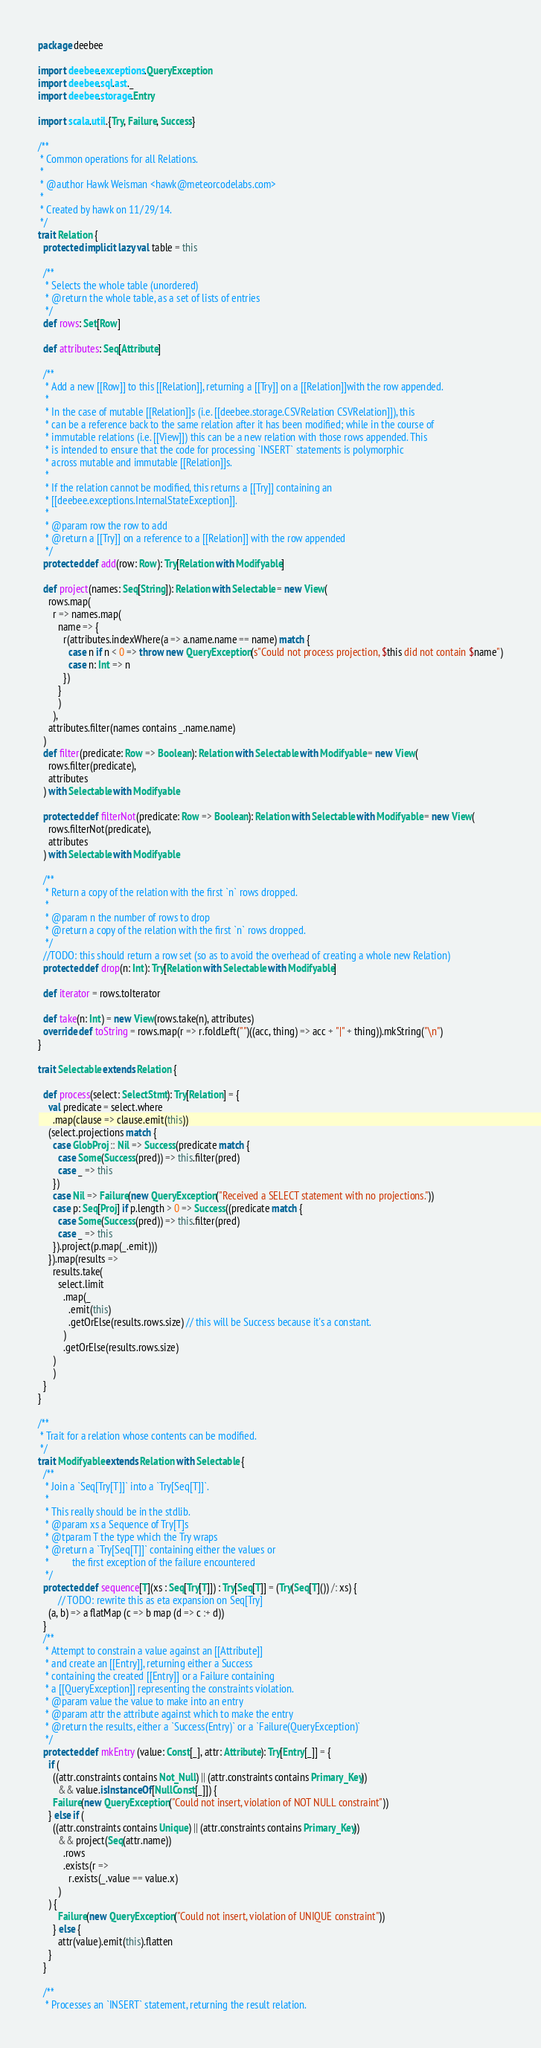<code> <loc_0><loc_0><loc_500><loc_500><_Scala_>package deebee

import deebee.exceptions.QueryException
import deebee.sql.ast._
import deebee.storage.Entry

import scala.util.{Try, Failure, Success}

/**
 * Common operations for all Relations.
 *
 * @author Hawk Weisman <hawk@meteorcodelabs.com>
 *
 * Created by hawk on 11/29/14.
 */
trait Relation {
  protected implicit lazy val table = this

  /**
   * Selects the whole table (unordered)
   * @return the whole table, as a set of lists of entries
   */
  def rows: Set[Row]

  def attributes: Seq[Attribute]

  /**
   * Add a new [[Row]] to this [[Relation]], returning a [[Try]] on a [[Relation]]with the row appended.
   *
   * In the case of mutable [[Relation]]s (i.e. [[deebee.storage.CSVRelation CSVRelation]]), this
   * can be a reference back to the same relation after it has been modified; while in the course of
   * immutable relations (i.e. [[View]]) this can be a new relation with those rows appended. This
   * is intended to ensure that the code for processing `INSERT` statements is polymorphic
   * across mutable and immutable [[Relation]]s.
   *
   * If the relation cannot be modified, this returns a [[Try]] containing an
   * [[deebee.exceptions.InternalStateException]].
   *
   * @param row the row to add
   * @return a [[Try]] on a reference to a [[Relation]] with the row appended
   */
  protected def add(row: Row): Try[Relation with Modifyable]

  def project(names: Seq[String]): Relation with Selectable = new View(
    rows.map(
      r => names.map(
        name => {
          r(attributes.indexWhere(a => a.name.name == name) match {
            case n if n < 0 => throw new QueryException(s"Could not process projection, $this did not contain $name")
            case n: Int => n
          })
        }
        )
      ),
    attributes.filter(names contains _.name.name)
  )
  def filter(predicate: Row => Boolean): Relation with Selectable with Modifyable = new View(
    rows.filter(predicate),
    attributes
  ) with Selectable with Modifyable

  protected def filterNot(predicate: Row => Boolean): Relation with Selectable with Modifyable = new View(
    rows.filterNot(predicate),
    attributes
  ) with Selectable with Modifyable

  /**
   * Return a copy of the relation with the first `n` rows dropped.
   *
   * @param n the number of rows to drop
   * @return a copy of the relation with the first `n` rows dropped.
   */
  //TODO: this should return a row set (so as to avoid the overhead of creating a whole new Relation)
  protected def drop(n: Int): Try[Relation with Selectable with Modifyable]

  def iterator = rows.toIterator

  def take(n: Int) = new View(rows.take(n), attributes)
  override def toString = rows.map(r => r.foldLeft("")((acc, thing) => acc + "|" + thing)).mkString("\n")
}

trait Selectable extends Relation {

  def process(select: SelectStmt): Try[Relation] = {
    val predicate = select.where
      .map(clause => clause.emit(this))
    (select.projections match {
      case GlobProj :: Nil => Success(predicate match {
        case Some(Success(pred)) => this.filter(pred)
        case _ => this
      })
      case Nil => Failure(new QueryException("Received a SELECT statement with no projections."))
      case p: Seq[Proj] if p.length > 0 => Success((predicate match {
        case Some(Success(pred)) => this.filter(pred)
        case _ => this
      }).project(p.map(_.emit)))
    }).map(results =>
      results.take(
        select.limit
          .map(_
            .emit(this)
            .getOrElse(results.rows.size) // this will be Success because it's a constant.
          )
          .getOrElse(results.rows.size)
      )
      )
  }
}

/**
 * Trait for a relation whose contents can be modified.
 */
trait Modifyable extends Relation with Selectable {
  /**
   * Join a `Seq[Try[T]]` into a `Try[Seq[T]]`.
   *
   * This really should be in the stdlib.
   * @param xs a Sequence of Try[T]s
   * @tparam T the type which the Try wraps
   * @return a `Try[Seq[T]]` containing either the values or
   *         the first exception of the failure encountered
   */
  protected def sequence[T](xs : Seq[Try[T]]) : Try[Seq[T]] = (Try(Seq[T]()) /: xs) {
        // TODO: rewrite this as eta expansion on Seq[Try]
    (a, b) => a flatMap (c => b map (d => c :+ d))
  }
  /**
   * Attempt to constrain a value against an [[Attribute]]
   * and create an [[Entry]], returning either a Success
   * containing the created [[Entry]] or a Failure containing
   * a [[QueryException]] representing the constraints violation.
   * @param value the value to make into an entry
   * @param attr the attribute against which to make the entry
   * @return the results, either a `Success(Entry)` or a `Failure(QueryException)`
   */
  protected def mkEntry (value: Const[_], attr: Attribute): Try[Entry[_]] = {
    if (
      ((attr.constraints contains Not_Null) || (attr.constraints contains Primary_Key))
        && value.isInstanceOf[NullConst[_]]) {
      Failure(new QueryException("Could not insert, violation of NOT NULL constraint"))
    } else if (
      ((attr.constraints contains Unique) || (attr.constraints contains Primary_Key))
        && project(Seq(attr.name))
          .rows
          .exists(r =>
            r.exists(_.value == value.x)
        )
    ) {
        Failure(new QueryException("Could not insert, violation of UNIQUE constraint"))
      } else {
        attr(value).emit(this).flatten
    }
  }

  /**
   * Processes an `INSERT` statement, returning the result relation.</code> 